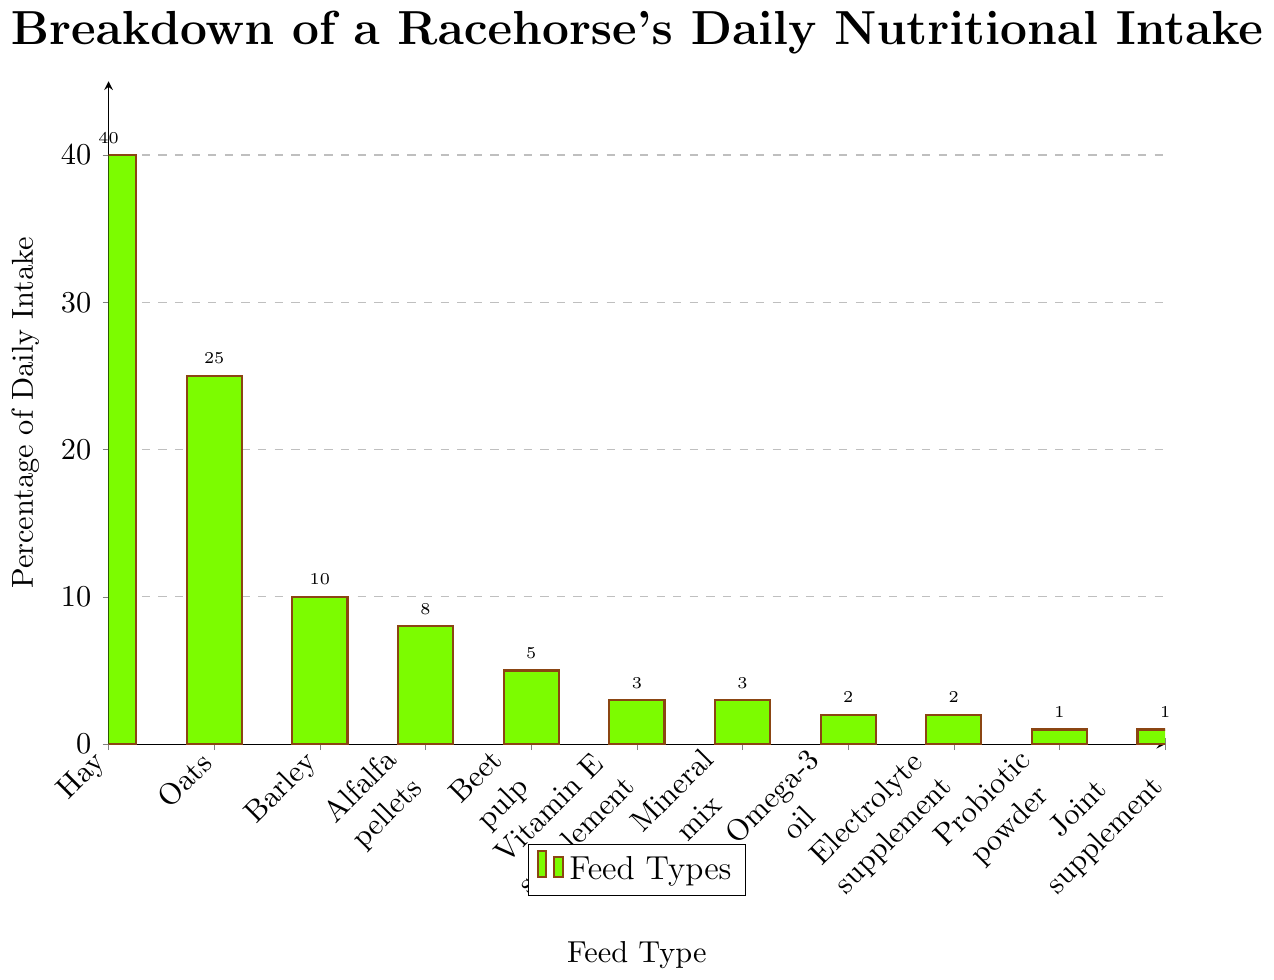What is the feed type that contributes the largest percentage of daily intake? Hay contributes the largest percentage of daily intake. The height of the bar for Hay is the highest at 40%, which is visually more than all other feed types.
Answer: Hay How much more does Hay contribute to the daily intake compared to Oats? Hay contributes 40%, and Oats contribute 25%. The difference between them is 40% - 25%.
Answer: 15% Which feed types contribute equally to the daily intake? By looking at the height of the bars, both Vitamin E supplement and Mineral mix contribute 3%, and both Omega-3 oil and Electrolyte supplement contribute 2%.
Answer: Vitamin E supplement and Mineral mix; Omega-3 oil and Electrolyte supplement What is the total percentage contributed by the various supplements? The supplements include Vitamin E supplement (3%), Mineral mix (3%), Omega-3 oil (2%), Electrolyte supplement (2%), Probiotic powder (1%), and Joint supplement (1%). Adding these values together gives 3% + 3% + 2% + 2% + 1% + 1% = 12%.
Answer: 12% If you combine the percentages of Oats and Barley, how does their total compare to that of Hay? Oats contribute 25% and Barley contributes 10%. Their combined total is 25% + 10% = 35%. The percentage for Hay is 40%. Therefore, their combined total is 5% less than that of Hay (40% - 35%).
Answer: 5% less What is the visual difference between the bars representing Hay and Beet pulp? The height of the bar for Hay is much taller compared to the Beet pulp. Hay has a percentage of 40%, while Beet pulp has a percentage of 5%. This means the height of Hay's bar is eight times that of Beet pulp's bar.
Answer: The bar for Hay is significantly taller than that for Beet pulp Which feed type contributes the least to the daily intake and what is its percentage? By examining the height of the bars, the shortest bars belong to Probiotic powder and Joint supplement, both contributing 1%.
Answer: Probiotic powder and Joint supplement, 1% What is the average percentage contribution of the first four feed types (Hay, Oats, Barley, Alfalfa pellets)? The percentages for the first four feed types are Hay (40%), Oats (25%), Barley (10%), Alfalfa pellets (8%). The average is calculated by (40% + 25% + 10% + 8%) / 4 = 83% / 4 = 20.75%.
Answer: 20.75% How much more does the combination of Hay and Oats contribute than all the supplements combined? Hay and Oats together contribute 40% + 25% = 65%. All the supplements combined contribute 12%. The difference is 65% - 12% = 53%.
Answer: 53% If the contributions of Alfalfa pellets and Beet pulp were combined, what percentage would they contribute and how would they rank compared to other feed types? Alfalfa pellets contribute 8% and Beet pulp contributes 5%. Combined, they contribute 8% + 5% = 13%. This 13% would make it the third highest after Hay (40%) and Oats (25%).
Answer: 13%, third highest 